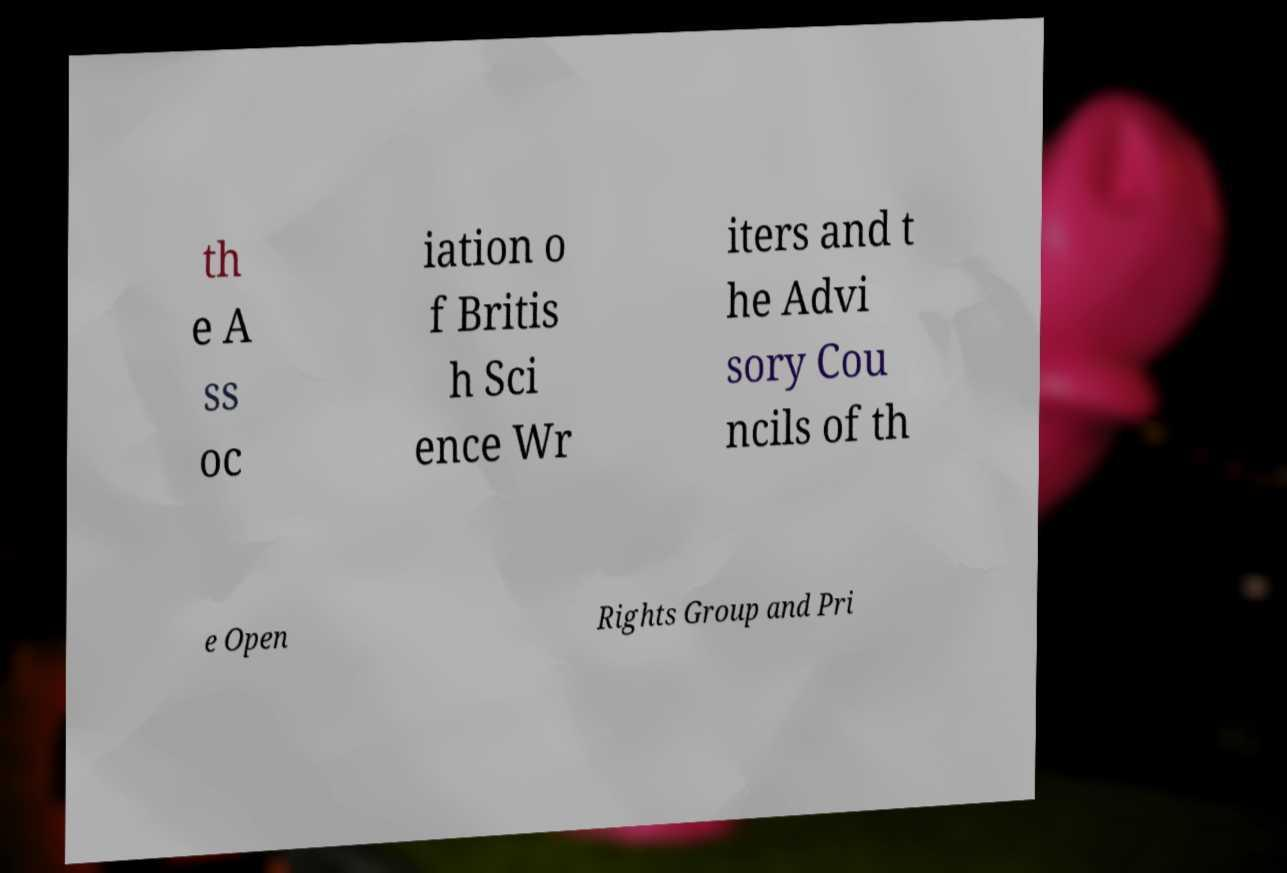For documentation purposes, I need the text within this image transcribed. Could you provide that? th e A ss oc iation o f Britis h Sci ence Wr iters and t he Advi sory Cou ncils of th e Open Rights Group and Pri 